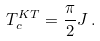<formula> <loc_0><loc_0><loc_500><loc_500>T _ { c } ^ { K T } = \frac { \pi } { 2 } J \, .</formula> 